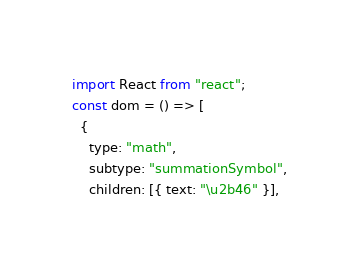<code> <loc_0><loc_0><loc_500><loc_500><_JavaScript_>import React from "react";
const dom = () => [
  {
    type: "math",
    subtype: "summationSymbol",
    children: [{ text: "\u2b46" }],</code> 